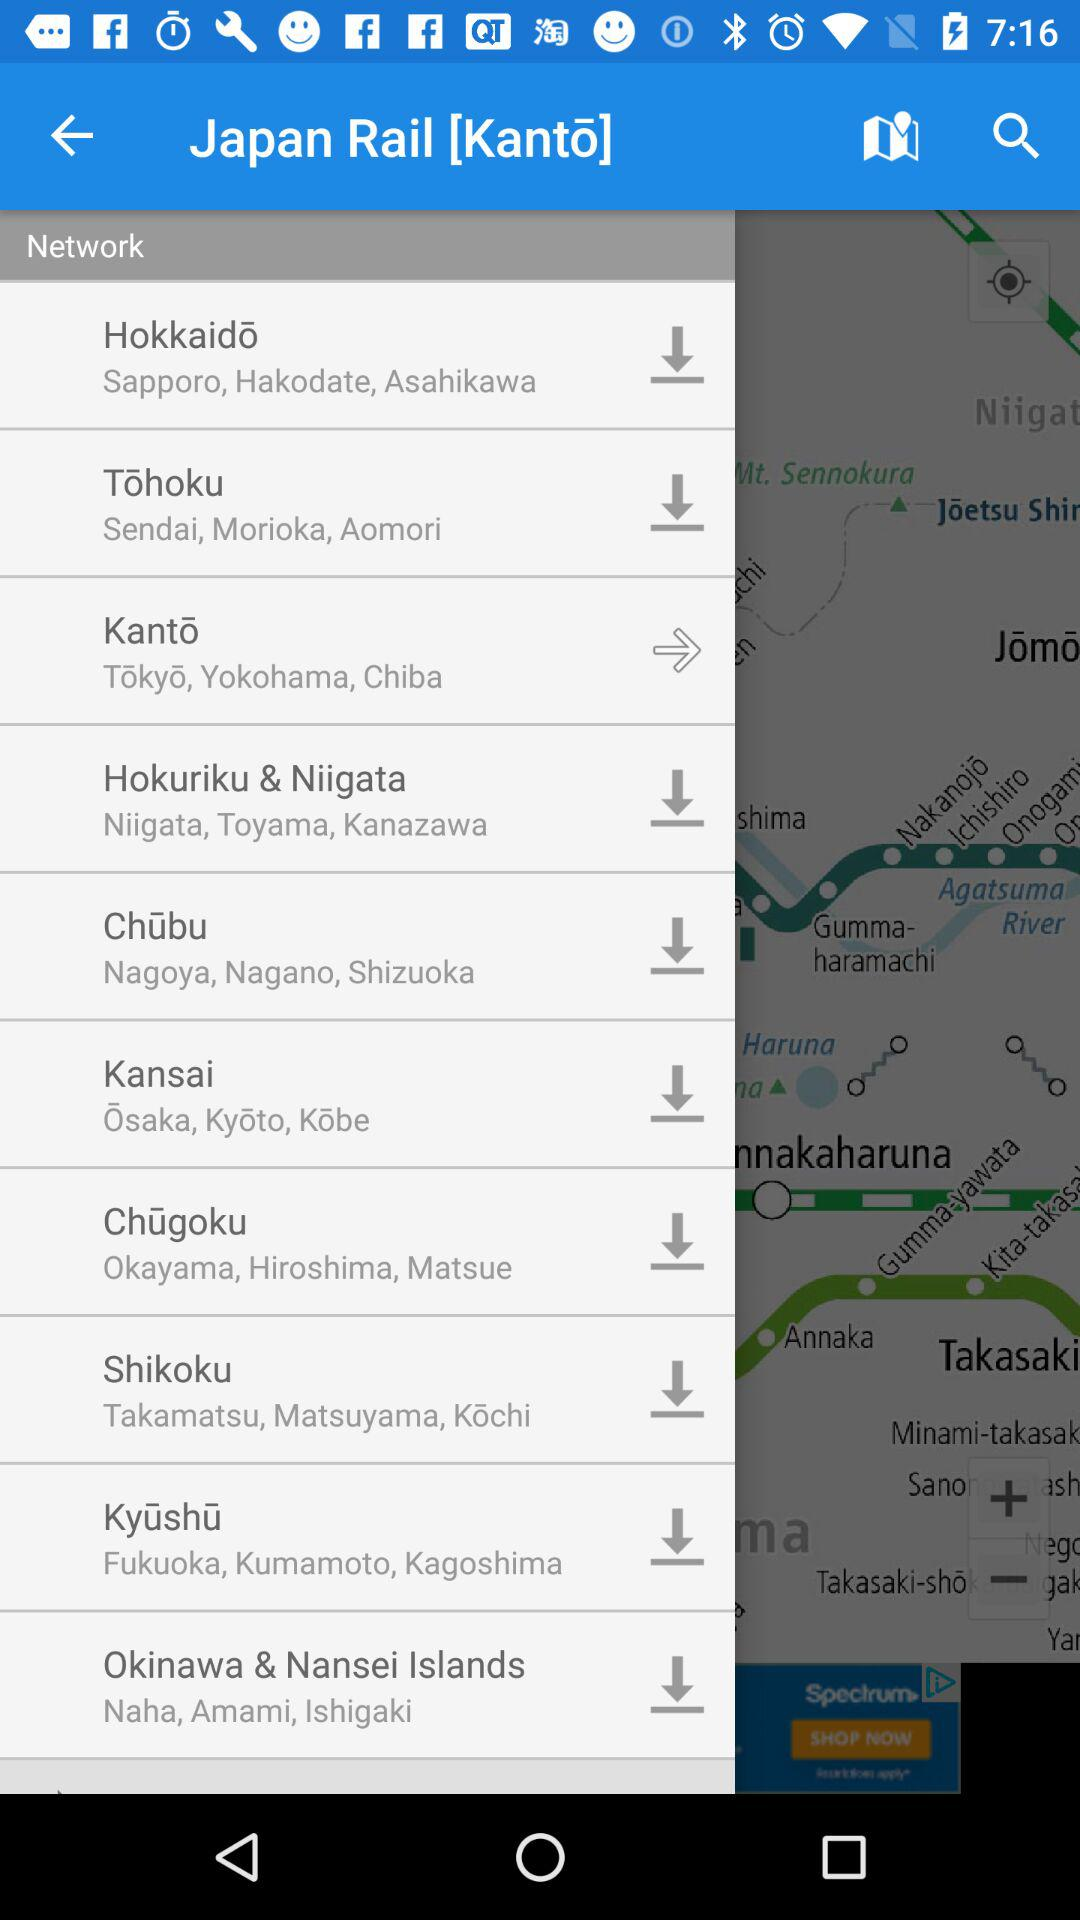How many regions are there on the map?
Answer the question using a single word or phrase. 10 